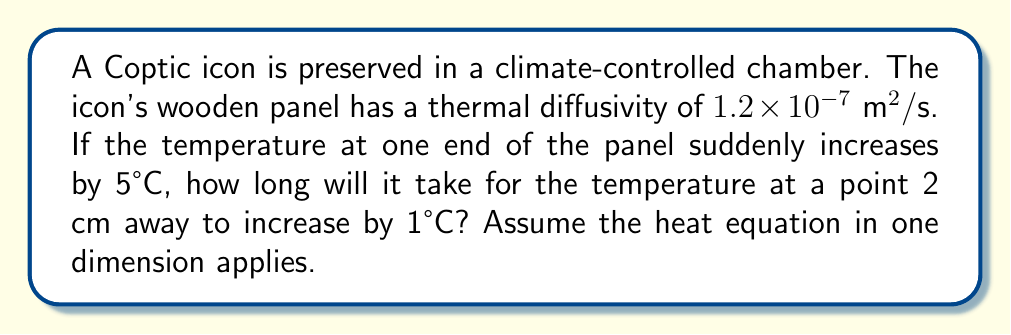Give your solution to this math problem. To solve this problem, we'll use the one-dimensional heat equation and its solution for a semi-infinite solid with a step change in surface temperature.

1) The heat equation in one dimension is:

   $$\frac{\partial T}{\partial t} = \alpha \frac{\partial^2 T}{\partial x^2}$$

   where $\alpha$ is the thermal diffusivity.

2) For a step change in surface temperature, the solution is:

   $$\frac{T(x,t) - T_i}{T_s - T_i} = \text{erfc}\left(\frac{x}{2\sqrt{\alpha t}}\right)$$

   where $T_i$ is the initial temperature, $T_s$ is the surface temperature, and erfc is the complementary error function.

3) We're looking for the time when the temperature rise is 1°C at x = 2 cm. So:

   $$\frac{1}{5} = \text{erfc}\left(\frac{0.02}{2\sqrt{1.2 \times 10^{-7} t}}\right)$$

4) From error function tables or calculators, we find that:

   $$\text{erfc}(0.9069) = 0.2$$

5) Therefore:

   $$\frac{0.02}{2\sqrt{1.2 \times 10^{-7} t}} = 0.9069$$

6) Solving for t:

   $$t = \frac{0.02^2}{4 \times (1.2 \times 10^{-7}) \times 0.9069^2} = 1018.7 \text{ seconds}$$

7) Rounding to the nearest second:

   $$t \approx 1019 \text{ seconds}$$
Answer: 1019 seconds 